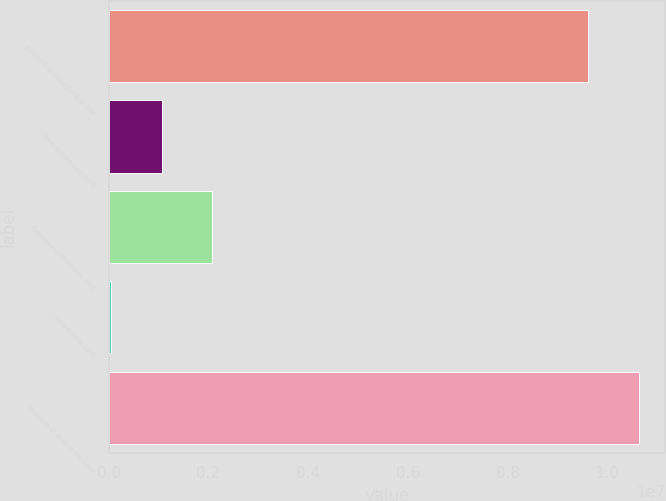<chart> <loc_0><loc_0><loc_500><loc_500><bar_chart><fcel>Balance at beginning of the<fcel>Real estate acquired<fcel>Capital expenditures and<fcel>Real estate sold<fcel>Balance at end of the year<nl><fcel>9.61575e+06<fcel>1.05693e+06<fcel>2.0703e+06<fcel>43569<fcel>1.06291e+07<nl></chart> 